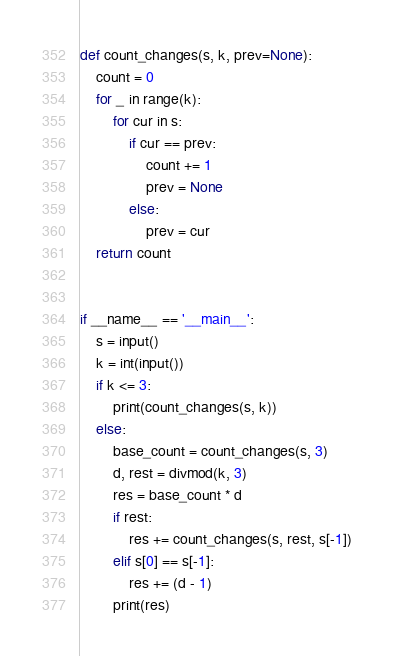<code> <loc_0><loc_0><loc_500><loc_500><_Python_>def count_changes(s, k, prev=None):
    count = 0
    for _ in range(k):
        for cur in s:
            if cur == prev:
                count += 1
                prev = None
            else:
                prev = cur
    return count


if __name__ == '__main__':
    s = input()
    k = int(input())
    if k <= 3:
        print(count_changes(s, k))
    else:
        base_count = count_changes(s, 3)
        d, rest = divmod(k, 3)
        res = base_count * d
        if rest:
            res += count_changes(s, rest, s[-1])
        elif s[0] == s[-1]:
            res += (d - 1)
        print(res)</code> 